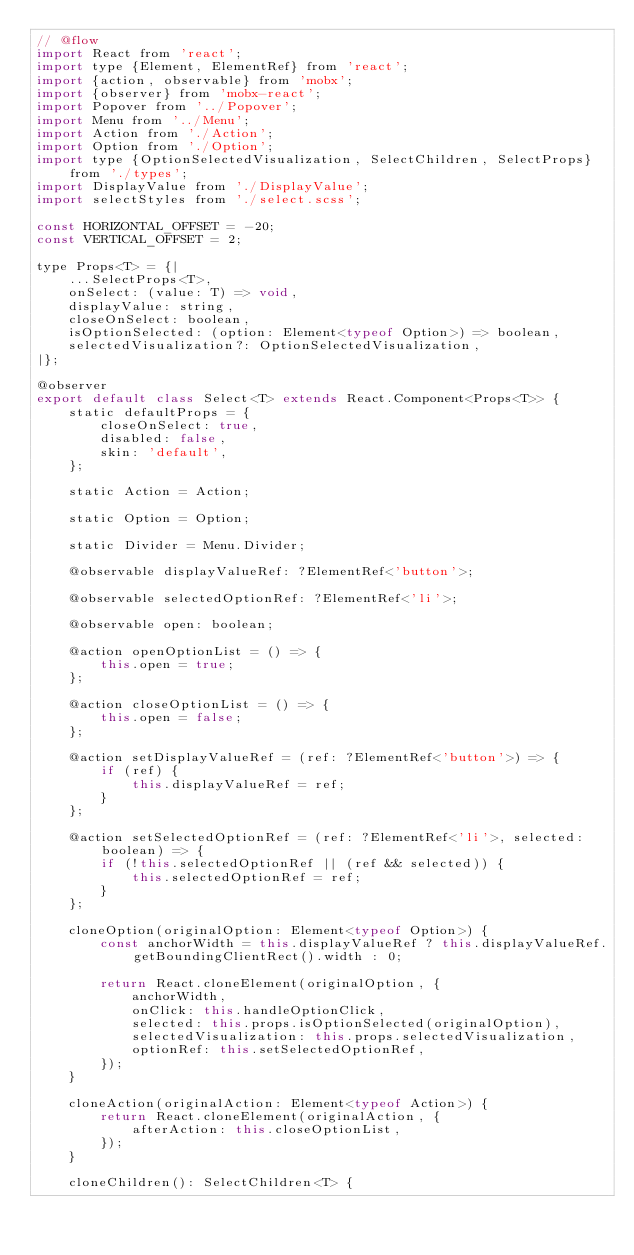<code> <loc_0><loc_0><loc_500><loc_500><_JavaScript_>// @flow
import React from 'react';
import type {Element, ElementRef} from 'react';
import {action, observable} from 'mobx';
import {observer} from 'mobx-react';
import Popover from '../Popover';
import Menu from '../Menu';
import Action from './Action';
import Option from './Option';
import type {OptionSelectedVisualization, SelectChildren, SelectProps} from './types';
import DisplayValue from './DisplayValue';
import selectStyles from './select.scss';

const HORIZONTAL_OFFSET = -20;
const VERTICAL_OFFSET = 2;

type Props<T> = {|
    ...SelectProps<T>,
    onSelect: (value: T) => void,
    displayValue: string,
    closeOnSelect: boolean,
    isOptionSelected: (option: Element<typeof Option>) => boolean,
    selectedVisualization?: OptionSelectedVisualization,
|};

@observer
export default class Select<T> extends React.Component<Props<T>> {
    static defaultProps = {
        closeOnSelect: true,
        disabled: false,
        skin: 'default',
    };

    static Action = Action;

    static Option = Option;

    static Divider = Menu.Divider;

    @observable displayValueRef: ?ElementRef<'button'>;

    @observable selectedOptionRef: ?ElementRef<'li'>;

    @observable open: boolean;

    @action openOptionList = () => {
        this.open = true;
    };

    @action closeOptionList = () => {
        this.open = false;
    };

    @action setDisplayValueRef = (ref: ?ElementRef<'button'>) => {
        if (ref) {
            this.displayValueRef = ref;
        }
    };

    @action setSelectedOptionRef = (ref: ?ElementRef<'li'>, selected: boolean) => {
        if (!this.selectedOptionRef || (ref && selected)) {
            this.selectedOptionRef = ref;
        }
    };

    cloneOption(originalOption: Element<typeof Option>) {
        const anchorWidth = this.displayValueRef ? this.displayValueRef.getBoundingClientRect().width : 0;

        return React.cloneElement(originalOption, {
            anchorWidth,
            onClick: this.handleOptionClick,
            selected: this.props.isOptionSelected(originalOption),
            selectedVisualization: this.props.selectedVisualization,
            optionRef: this.setSelectedOptionRef,
        });
    }

    cloneAction(originalAction: Element<typeof Action>) {
        return React.cloneElement(originalAction, {
            afterAction: this.closeOptionList,
        });
    }

    cloneChildren(): SelectChildren<T> {</code> 